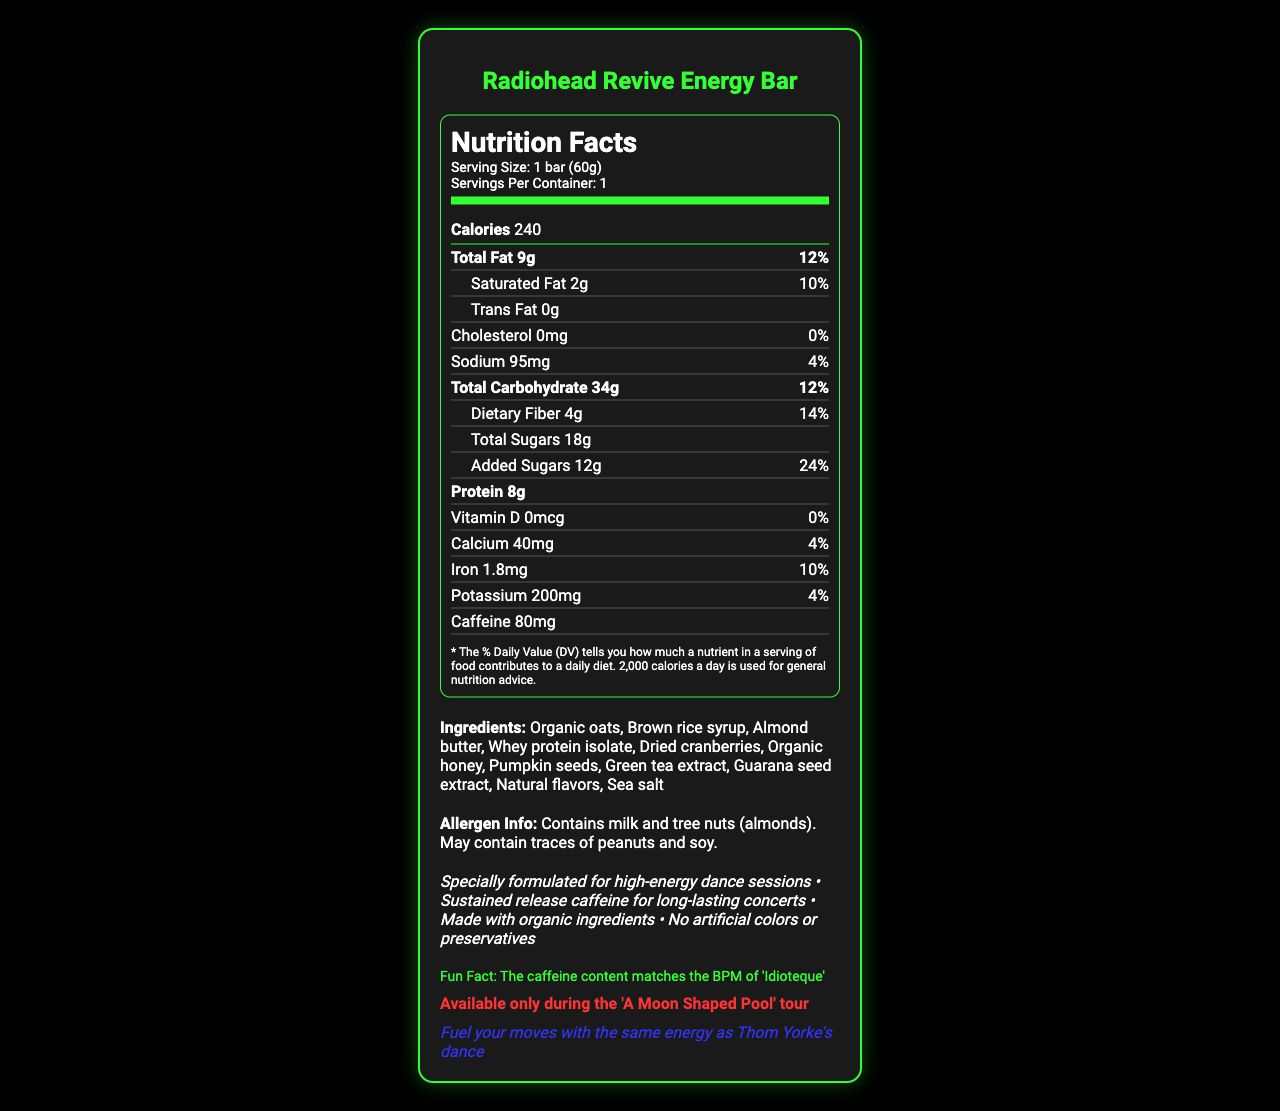which ingredient is listed first? Ingredients are listed in the order they appear, and "Organic oats" is the first one listed.
Answer: Organic oats what is the serving size of the Radiohead Revive Energy Bar? The serving size is specified as "1 bar (60g)" in the document.
Answer: 1 bar (60g) how many calories are there in one serving? The document lists "Calories 240" under the nutrition facts.
Answer: 240 calories what is the total amount of fat in the energy bar? The total fat content is listed as "Total Fat 9g" in the nutrition facts.
Answer: 9g what is the caffeine content in the bar? The caffeine content is listed as "Caffeine 80mg" under the nutrition facts.
Answer: 80mg which type of fats does the bar contain? A. Saturated fat B. Trans fat C. Both D. None The bar contains 2g of saturated fat and 0g of trans fat as listed in the document.
Answer: C. Both what percentage of daily value is the saturated fat content? A. 10% B. 12% C. 14% D. 24% The document lists "Saturated Fat 2g" and "10%" as the daily value.
Answer: A. 10% does the energy bar contain any artificial colors or preservatives? The marketing claims in the document state "No artificial colors or preservatives."
Answer: No is the caffeine content synchronized with a Radiohead song? The trivia section states "The caffeine content matches the BPM of 'Idioteque'."
Answer: Yes is the product available outside the 'A Moon Shaped Pool' tour? The limited edition information states that it is "Available only during the 'A Moon Shaped Pool' tour."
Answer: No summarize the nutritional highlights of the Radiohead Revive Energy Bar. The document highlights the nutritional content, ingredients, special features, and intended target audience of the energy bar, emphasizing its suitability for high-energy activities and its natural composition.
Answer: The Radiohead Revive Energy Bar is designed for high-energy dance sessions, offering 240 calories per bar, with 9g of total fat, 34g of carbohydrates (including 4g dietary fiber and 18g total sugars with 12g added sugars), and 8g of protein. It contains 80mg of caffeine and various nutrients like calcium, iron, and potassium. Made with organic ingredients and devoid of artificial colors and preservatives, it fuels fans with sustained energy throughout long concerts. what is the main ingredient used for sweetening in the bar? The ingredients list includes "Brown rice syrup" and "Organic honey," which are common sweetening agents.
Answer: Brown rice syrup and organic honey what is the content of vitamin D in the bar? The document states "Vitamin D 0mcg".
Answer: 0mcg how much protein does one bar provide? The nutrition label lists "Protein 8g".
Answer: 8g what allergens does the energy bar contain? The allergen information states that the bar contains "milk and tree nuts (almonds)" and may contain traces of peanuts and soy.
Answer: Milk and tree nuts (almonds) does the bar include any added sugars? The nutrition facts specify that the bar contains "Added Sugars 12g" with a daily value of 24%.
Answer: Yes what are the primary ingredients providing protein in the bar? From the ingredients list, "Almond butter" and "Whey protein isolate" are the primary sources of protein.
Answer: Almond butter and whey protein isolate how does the document describe the fan experience? The fan experience section mentions to "Fuel your moves with the same energy as Thom Yorke's dance."
Answer: Fuel your moves with the same energy as Thom Yorke's dance how much sodium does the energy bar contain? The sodium content is listed as "Sodium 95mg" in the nutrition facts.
Answer: 95mg does the document provide any information about other products in the Radiohead-themed line? The document solely focuses on the Radiohead Revive Energy Bar and does not mention other products.
Answer: Not enough information 